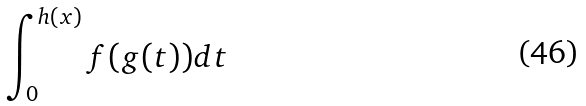<formula> <loc_0><loc_0><loc_500><loc_500>\int _ { 0 } ^ { h ( x ) } f ( g ( t ) ) d t</formula> 